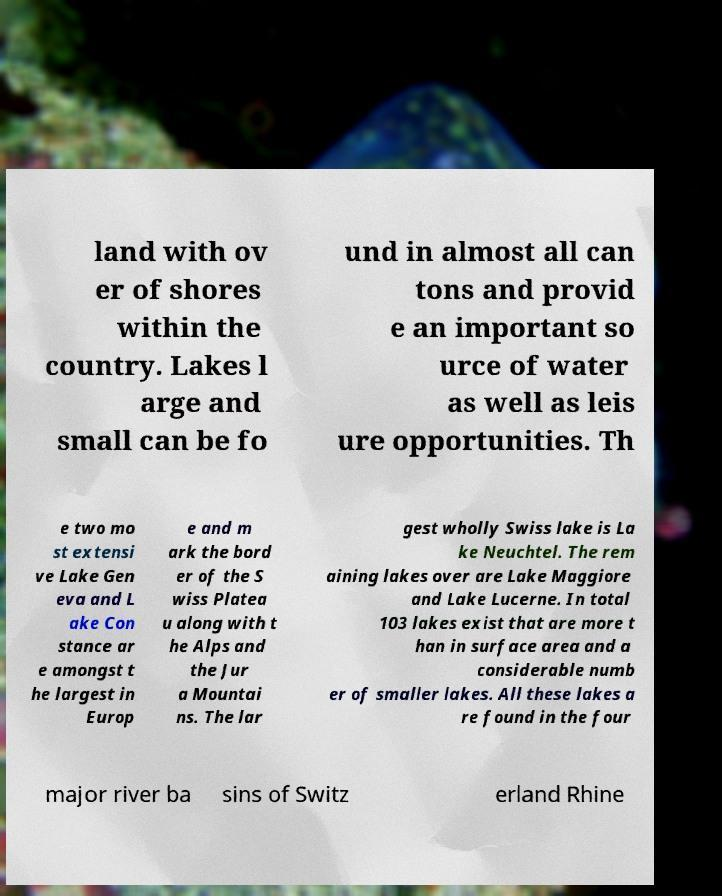Can you read and provide the text displayed in the image?This photo seems to have some interesting text. Can you extract and type it out for me? land with ov er of shores within the country. Lakes l arge and small can be fo und in almost all can tons and provid e an important so urce of water as well as leis ure opportunities. Th e two mo st extensi ve Lake Gen eva and L ake Con stance ar e amongst t he largest in Europ e and m ark the bord er of the S wiss Platea u along with t he Alps and the Jur a Mountai ns. The lar gest wholly Swiss lake is La ke Neuchtel. The rem aining lakes over are Lake Maggiore and Lake Lucerne. In total 103 lakes exist that are more t han in surface area and a considerable numb er of smaller lakes. All these lakes a re found in the four major river ba sins of Switz erland Rhine 